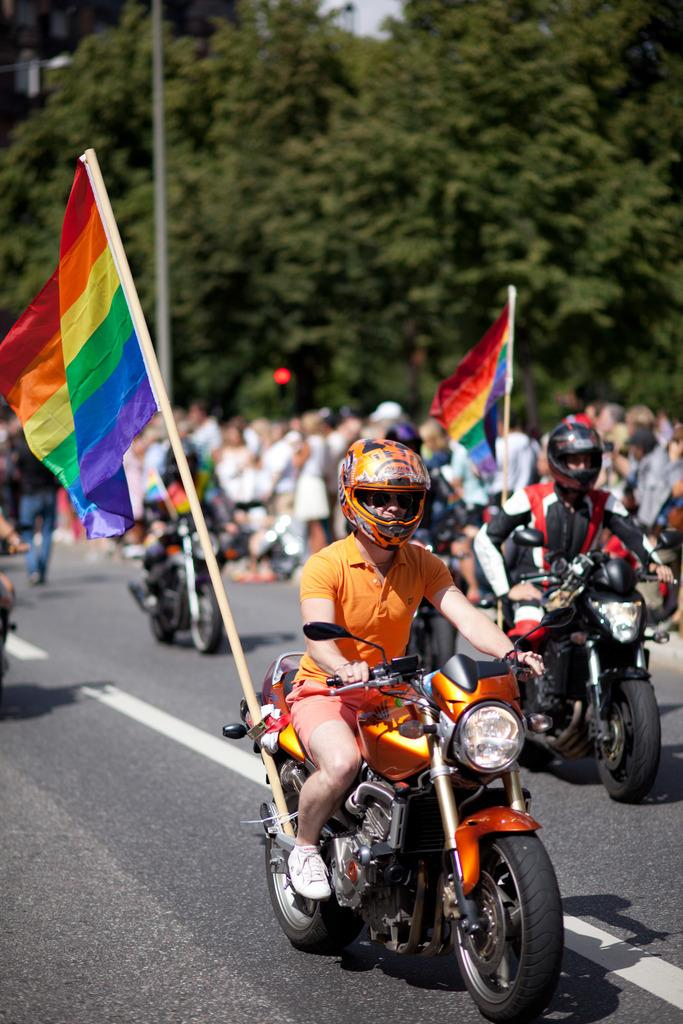What are the people in the image doing? There is a group of people standing on the ground, and there are people riding a bike. Can you describe the bike in the image? The bike has a flag attached to it. What type of steel is used to construct the square plough in the image? There is no steel, square, or plough present in the image. 